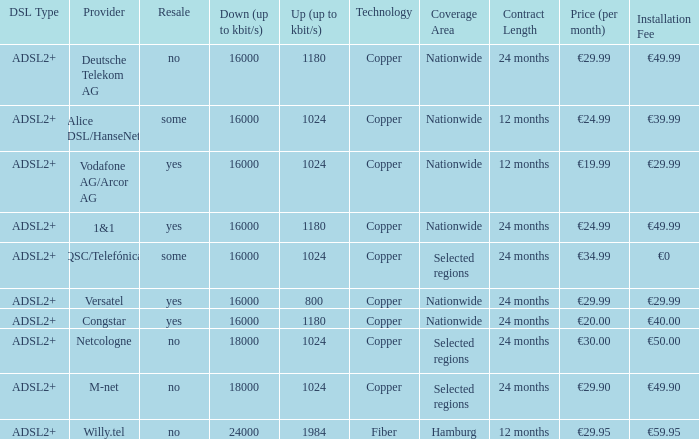What is download bandwith where the provider is deutsche telekom ag? 16000.0. 